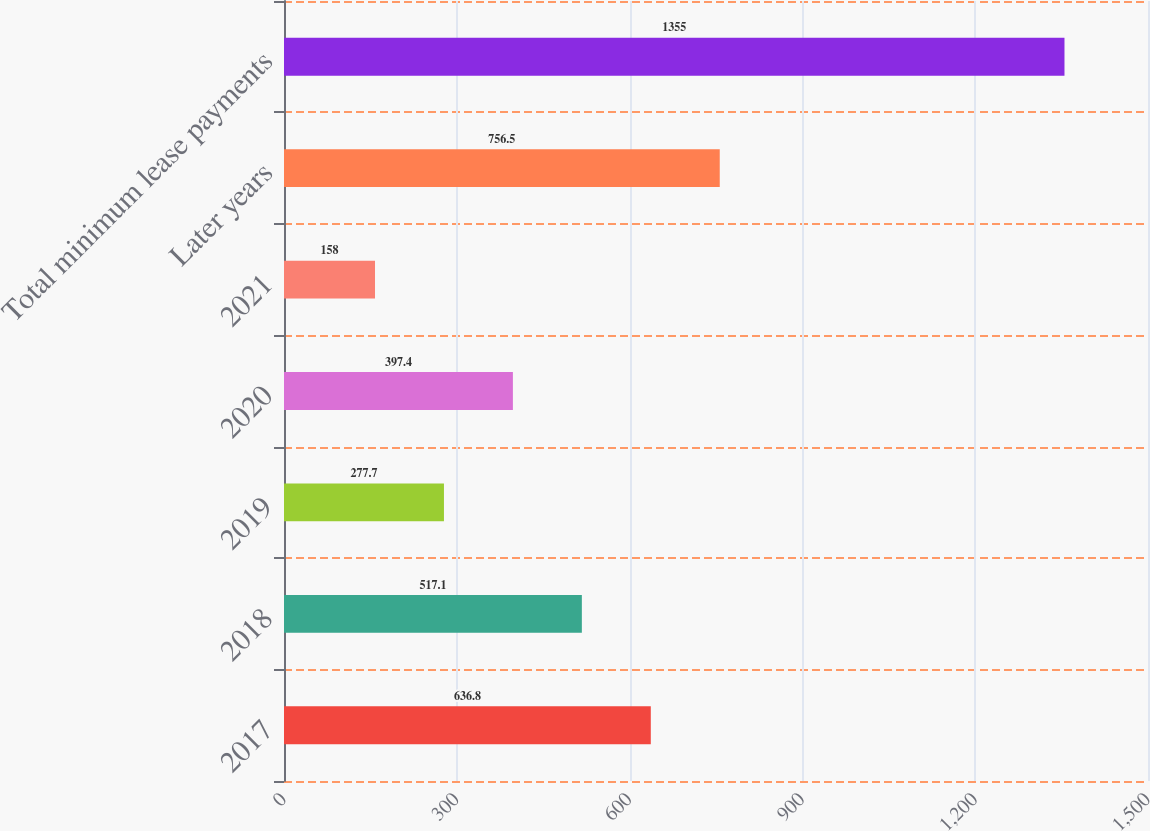Convert chart. <chart><loc_0><loc_0><loc_500><loc_500><bar_chart><fcel>2017<fcel>2018<fcel>2019<fcel>2020<fcel>2021<fcel>Later years<fcel>Total minimum lease payments<nl><fcel>636.8<fcel>517.1<fcel>277.7<fcel>397.4<fcel>158<fcel>756.5<fcel>1355<nl></chart> 